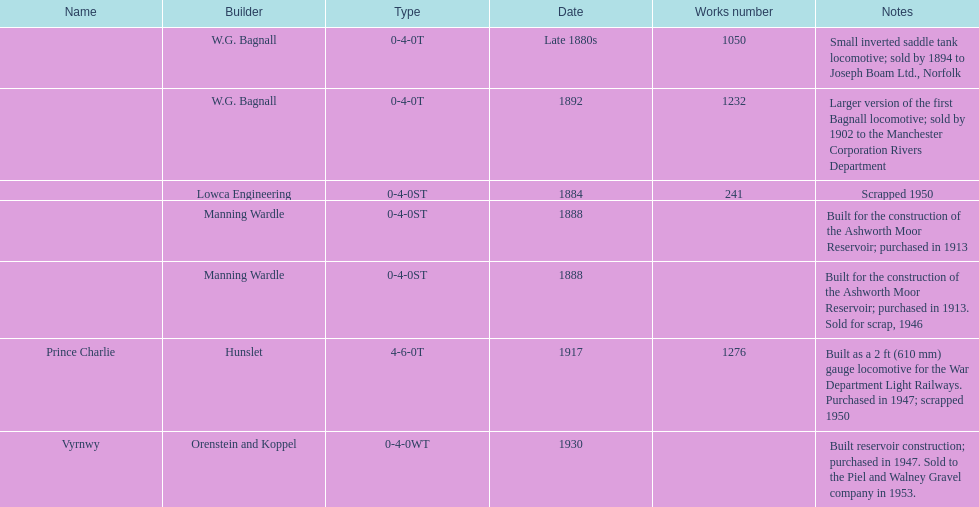Which locomotive builder built a locomotive after 1888 and built the locomotive as a 2ft gauge locomotive? Hunslet. 